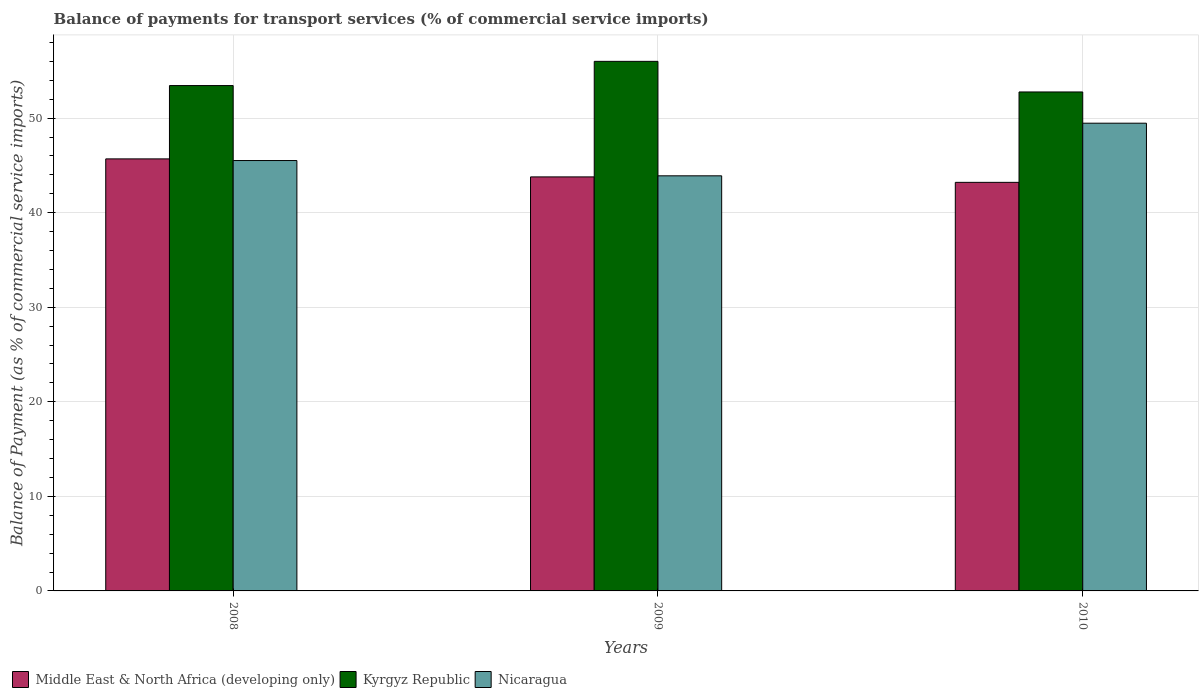Are the number of bars per tick equal to the number of legend labels?
Offer a terse response. Yes. Are the number of bars on each tick of the X-axis equal?
Make the answer very short. Yes. How many bars are there on the 2nd tick from the left?
Offer a very short reply. 3. How many bars are there on the 3rd tick from the right?
Provide a succinct answer. 3. What is the label of the 1st group of bars from the left?
Ensure brevity in your answer.  2008. What is the balance of payments for transport services in Kyrgyz Republic in 2010?
Your response must be concise. 52.77. Across all years, what is the maximum balance of payments for transport services in Nicaragua?
Your response must be concise. 49.46. Across all years, what is the minimum balance of payments for transport services in Middle East & North Africa (developing only)?
Provide a short and direct response. 43.21. What is the total balance of payments for transport services in Nicaragua in the graph?
Keep it short and to the point. 138.87. What is the difference between the balance of payments for transport services in Kyrgyz Republic in 2008 and that in 2010?
Offer a terse response. 0.68. What is the difference between the balance of payments for transport services in Middle East & North Africa (developing only) in 2008 and the balance of payments for transport services in Nicaragua in 2009?
Your answer should be very brief. 1.79. What is the average balance of payments for transport services in Nicaragua per year?
Your response must be concise. 46.29. In the year 2010, what is the difference between the balance of payments for transport services in Nicaragua and balance of payments for transport services in Kyrgyz Republic?
Provide a short and direct response. -3.3. In how many years, is the balance of payments for transport services in Nicaragua greater than 24 %?
Offer a very short reply. 3. What is the ratio of the balance of payments for transport services in Nicaragua in 2009 to that in 2010?
Your response must be concise. 0.89. What is the difference between the highest and the second highest balance of payments for transport services in Nicaragua?
Your answer should be very brief. 3.95. What is the difference between the highest and the lowest balance of payments for transport services in Middle East & North Africa (developing only)?
Provide a succinct answer. 2.48. Is the sum of the balance of payments for transport services in Middle East & North Africa (developing only) in 2008 and 2010 greater than the maximum balance of payments for transport services in Nicaragua across all years?
Make the answer very short. Yes. What does the 1st bar from the left in 2009 represents?
Provide a succinct answer. Middle East & North Africa (developing only). What does the 1st bar from the right in 2010 represents?
Keep it short and to the point. Nicaragua. How many bars are there?
Offer a very short reply. 9. Are all the bars in the graph horizontal?
Give a very brief answer. No. How many years are there in the graph?
Provide a short and direct response. 3. Are the values on the major ticks of Y-axis written in scientific E-notation?
Offer a very short reply. No. How many legend labels are there?
Keep it short and to the point. 3. How are the legend labels stacked?
Your answer should be very brief. Horizontal. What is the title of the graph?
Provide a short and direct response. Balance of payments for transport services (% of commercial service imports). Does "El Salvador" appear as one of the legend labels in the graph?
Ensure brevity in your answer.  No. What is the label or title of the X-axis?
Keep it short and to the point. Years. What is the label or title of the Y-axis?
Offer a very short reply. Balance of Payment (as % of commercial service imports). What is the Balance of Payment (as % of commercial service imports) of Middle East & North Africa (developing only) in 2008?
Offer a terse response. 45.69. What is the Balance of Payment (as % of commercial service imports) in Kyrgyz Republic in 2008?
Make the answer very short. 53.44. What is the Balance of Payment (as % of commercial service imports) in Nicaragua in 2008?
Your answer should be compact. 45.51. What is the Balance of Payment (as % of commercial service imports) of Middle East & North Africa (developing only) in 2009?
Make the answer very short. 43.78. What is the Balance of Payment (as % of commercial service imports) of Kyrgyz Republic in 2009?
Offer a very short reply. 56. What is the Balance of Payment (as % of commercial service imports) in Nicaragua in 2009?
Your answer should be compact. 43.9. What is the Balance of Payment (as % of commercial service imports) of Middle East & North Africa (developing only) in 2010?
Offer a terse response. 43.21. What is the Balance of Payment (as % of commercial service imports) in Kyrgyz Republic in 2010?
Provide a short and direct response. 52.77. What is the Balance of Payment (as % of commercial service imports) in Nicaragua in 2010?
Keep it short and to the point. 49.46. Across all years, what is the maximum Balance of Payment (as % of commercial service imports) of Middle East & North Africa (developing only)?
Provide a short and direct response. 45.69. Across all years, what is the maximum Balance of Payment (as % of commercial service imports) in Kyrgyz Republic?
Provide a succinct answer. 56. Across all years, what is the maximum Balance of Payment (as % of commercial service imports) in Nicaragua?
Your answer should be very brief. 49.46. Across all years, what is the minimum Balance of Payment (as % of commercial service imports) in Middle East & North Africa (developing only)?
Provide a short and direct response. 43.21. Across all years, what is the minimum Balance of Payment (as % of commercial service imports) in Kyrgyz Republic?
Give a very brief answer. 52.77. Across all years, what is the minimum Balance of Payment (as % of commercial service imports) of Nicaragua?
Offer a terse response. 43.9. What is the total Balance of Payment (as % of commercial service imports) of Middle East & North Africa (developing only) in the graph?
Ensure brevity in your answer.  132.68. What is the total Balance of Payment (as % of commercial service imports) of Kyrgyz Republic in the graph?
Make the answer very short. 162.21. What is the total Balance of Payment (as % of commercial service imports) of Nicaragua in the graph?
Provide a short and direct response. 138.87. What is the difference between the Balance of Payment (as % of commercial service imports) in Middle East & North Africa (developing only) in 2008 and that in 2009?
Provide a succinct answer. 1.9. What is the difference between the Balance of Payment (as % of commercial service imports) of Kyrgyz Republic in 2008 and that in 2009?
Offer a very short reply. -2.56. What is the difference between the Balance of Payment (as % of commercial service imports) of Nicaragua in 2008 and that in 2009?
Provide a short and direct response. 1.62. What is the difference between the Balance of Payment (as % of commercial service imports) of Middle East & North Africa (developing only) in 2008 and that in 2010?
Offer a terse response. 2.48. What is the difference between the Balance of Payment (as % of commercial service imports) in Kyrgyz Republic in 2008 and that in 2010?
Your answer should be compact. 0.68. What is the difference between the Balance of Payment (as % of commercial service imports) in Nicaragua in 2008 and that in 2010?
Your answer should be compact. -3.95. What is the difference between the Balance of Payment (as % of commercial service imports) in Middle East & North Africa (developing only) in 2009 and that in 2010?
Provide a succinct answer. 0.58. What is the difference between the Balance of Payment (as % of commercial service imports) in Kyrgyz Republic in 2009 and that in 2010?
Provide a short and direct response. 3.24. What is the difference between the Balance of Payment (as % of commercial service imports) of Nicaragua in 2009 and that in 2010?
Offer a terse response. -5.57. What is the difference between the Balance of Payment (as % of commercial service imports) of Middle East & North Africa (developing only) in 2008 and the Balance of Payment (as % of commercial service imports) of Kyrgyz Republic in 2009?
Your response must be concise. -10.31. What is the difference between the Balance of Payment (as % of commercial service imports) of Middle East & North Africa (developing only) in 2008 and the Balance of Payment (as % of commercial service imports) of Nicaragua in 2009?
Your answer should be compact. 1.79. What is the difference between the Balance of Payment (as % of commercial service imports) of Kyrgyz Republic in 2008 and the Balance of Payment (as % of commercial service imports) of Nicaragua in 2009?
Offer a terse response. 9.54. What is the difference between the Balance of Payment (as % of commercial service imports) of Middle East & North Africa (developing only) in 2008 and the Balance of Payment (as % of commercial service imports) of Kyrgyz Republic in 2010?
Offer a terse response. -7.08. What is the difference between the Balance of Payment (as % of commercial service imports) in Middle East & North Africa (developing only) in 2008 and the Balance of Payment (as % of commercial service imports) in Nicaragua in 2010?
Keep it short and to the point. -3.78. What is the difference between the Balance of Payment (as % of commercial service imports) in Kyrgyz Republic in 2008 and the Balance of Payment (as % of commercial service imports) in Nicaragua in 2010?
Give a very brief answer. 3.98. What is the difference between the Balance of Payment (as % of commercial service imports) in Middle East & North Africa (developing only) in 2009 and the Balance of Payment (as % of commercial service imports) in Kyrgyz Republic in 2010?
Keep it short and to the point. -8.98. What is the difference between the Balance of Payment (as % of commercial service imports) in Middle East & North Africa (developing only) in 2009 and the Balance of Payment (as % of commercial service imports) in Nicaragua in 2010?
Provide a succinct answer. -5.68. What is the difference between the Balance of Payment (as % of commercial service imports) of Kyrgyz Republic in 2009 and the Balance of Payment (as % of commercial service imports) of Nicaragua in 2010?
Make the answer very short. 6.54. What is the average Balance of Payment (as % of commercial service imports) in Middle East & North Africa (developing only) per year?
Offer a very short reply. 44.23. What is the average Balance of Payment (as % of commercial service imports) in Kyrgyz Republic per year?
Provide a succinct answer. 54.07. What is the average Balance of Payment (as % of commercial service imports) in Nicaragua per year?
Make the answer very short. 46.29. In the year 2008, what is the difference between the Balance of Payment (as % of commercial service imports) in Middle East & North Africa (developing only) and Balance of Payment (as % of commercial service imports) in Kyrgyz Republic?
Provide a short and direct response. -7.75. In the year 2008, what is the difference between the Balance of Payment (as % of commercial service imports) in Middle East & North Africa (developing only) and Balance of Payment (as % of commercial service imports) in Nicaragua?
Your answer should be compact. 0.17. In the year 2008, what is the difference between the Balance of Payment (as % of commercial service imports) in Kyrgyz Republic and Balance of Payment (as % of commercial service imports) in Nicaragua?
Offer a very short reply. 7.93. In the year 2009, what is the difference between the Balance of Payment (as % of commercial service imports) in Middle East & North Africa (developing only) and Balance of Payment (as % of commercial service imports) in Kyrgyz Republic?
Give a very brief answer. -12.22. In the year 2009, what is the difference between the Balance of Payment (as % of commercial service imports) of Middle East & North Africa (developing only) and Balance of Payment (as % of commercial service imports) of Nicaragua?
Ensure brevity in your answer.  -0.11. In the year 2009, what is the difference between the Balance of Payment (as % of commercial service imports) in Kyrgyz Republic and Balance of Payment (as % of commercial service imports) in Nicaragua?
Your answer should be very brief. 12.1. In the year 2010, what is the difference between the Balance of Payment (as % of commercial service imports) of Middle East & North Africa (developing only) and Balance of Payment (as % of commercial service imports) of Kyrgyz Republic?
Your response must be concise. -9.56. In the year 2010, what is the difference between the Balance of Payment (as % of commercial service imports) of Middle East & North Africa (developing only) and Balance of Payment (as % of commercial service imports) of Nicaragua?
Your response must be concise. -6.26. In the year 2010, what is the difference between the Balance of Payment (as % of commercial service imports) of Kyrgyz Republic and Balance of Payment (as % of commercial service imports) of Nicaragua?
Provide a short and direct response. 3.3. What is the ratio of the Balance of Payment (as % of commercial service imports) in Middle East & North Africa (developing only) in 2008 to that in 2009?
Your answer should be very brief. 1.04. What is the ratio of the Balance of Payment (as % of commercial service imports) of Kyrgyz Republic in 2008 to that in 2009?
Offer a very short reply. 0.95. What is the ratio of the Balance of Payment (as % of commercial service imports) in Nicaragua in 2008 to that in 2009?
Your answer should be very brief. 1.04. What is the ratio of the Balance of Payment (as % of commercial service imports) in Middle East & North Africa (developing only) in 2008 to that in 2010?
Offer a terse response. 1.06. What is the ratio of the Balance of Payment (as % of commercial service imports) in Kyrgyz Republic in 2008 to that in 2010?
Your response must be concise. 1.01. What is the ratio of the Balance of Payment (as % of commercial service imports) in Nicaragua in 2008 to that in 2010?
Offer a very short reply. 0.92. What is the ratio of the Balance of Payment (as % of commercial service imports) in Middle East & North Africa (developing only) in 2009 to that in 2010?
Your answer should be compact. 1.01. What is the ratio of the Balance of Payment (as % of commercial service imports) of Kyrgyz Republic in 2009 to that in 2010?
Your response must be concise. 1.06. What is the ratio of the Balance of Payment (as % of commercial service imports) of Nicaragua in 2009 to that in 2010?
Make the answer very short. 0.89. What is the difference between the highest and the second highest Balance of Payment (as % of commercial service imports) in Middle East & North Africa (developing only)?
Your response must be concise. 1.9. What is the difference between the highest and the second highest Balance of Payment (as % of commercial service imports) in Kyrgyz Republic?
Your response must be concise. 2.56. What is the difference between the highest and the second highest Balance of Payment (as % of commercial service imports) of Nicaragua?
Your response must be concise. 3.95. What is the difference between the highest and the lowest Balance of Payment (as % of commercial service imports) of Middle East & North Africa (developing only)?
Offer a terse response. 2.48. What is the difference between the highest and the lowest Balance of Payment (as % of commercial service imports) in Kyrgyz Republic?
Keep it short and to the point. 3.24. What is the difference between the highest and the lowest Balance of Payment (as % of commercial service imports) of Nicaragua?
Your answer should be very brief. 5.57. 